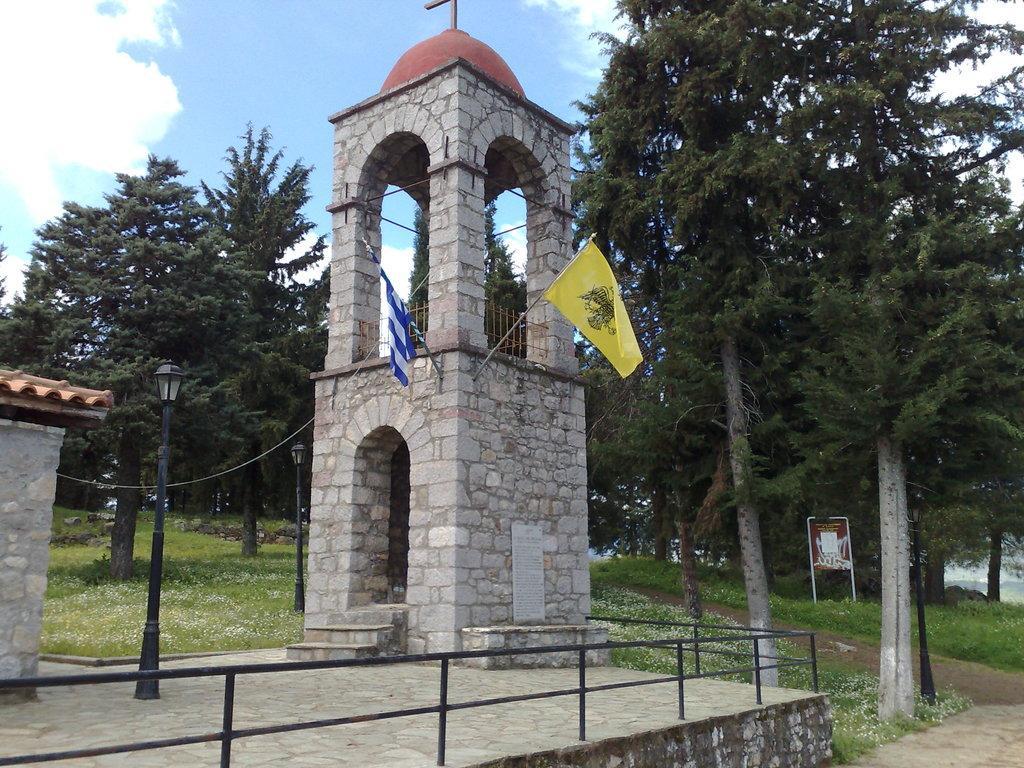Could you give a brief overview of what you see in this image? In this image we can see an arch with two flags, at the bottom we can see the fence, near that we can see street lights, we can see the trees and grass in the background, at the top we can see the sky with clouds. 